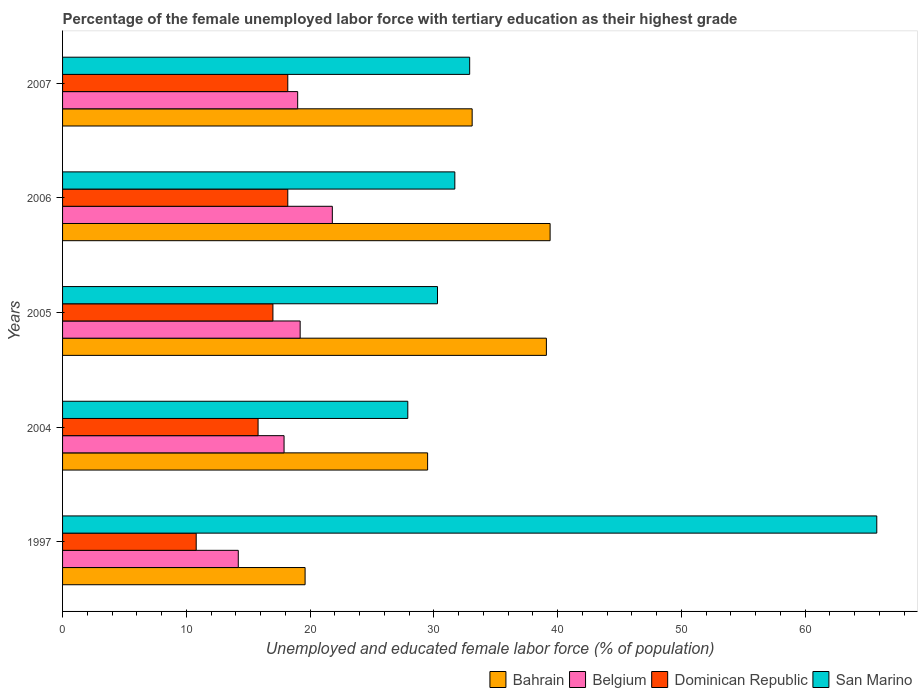How many bars are there on the 2nd tick from the top?
Your response must be concise. 4. What is the label of the 1st group of bars from the top?
Provide a succinct answer. 2007. What is the percentage of the unemployed female labor force with tertiary education in Bahrain in 1997?
Provide a succinct answer. 19.6. Across all years, what is the maximum percentage of the unemployed female labor force with tertiary education in San Marino?
Your answer should be compact. 65.8. Across all years, what is the minimum percentage of the unemployed female labor force with tertiary education in Dominican Republic?
Provide a succinct answer. 10.8. In which year was the percentage of the unemployed female labor force with tertiary education in Dominican Republic minimum?
Make the answer very short. 1997. What is the total percentage of the unemployed female labor force with tertiary education in Dominican Republic in the graph?
Your response must be concise. 80. What is the difference between the percentage of the unemployed female labor force with tertiary education in San Marino in 2006 and that in 2007?
Keep it short and to the point. -1.2. What is the difference between the percentage of the unemployed female labor force with tertiary education in Belgium in 2006 and the percentage of the unemployed female labor force with tertiary education in Dominican Republic in 1997?
Keep it short and to the point. 11. What is the average percentage of the unemployed female labor force with tertiary education in Belgium per year?
Offer a very short reply. 18.42. In the year 2005, what is the difference between the percentage of the unemployed female labor force with tertiary education in Belgium and percentage of the unemployed female labor force with tertiary education in Dominican Republic?
Make the answer very short. 2.2. What is the ratio of the percentage of the unemployed female labor force with tertiary education in San Marino in 1997 to that in 2005?
Provide a short and direct response. 2.17. Is the difference between the percentage of the unemployed female labor force with tertiary education in Belgium in 1997 and 2005 greater than the difference between the percentage of the unemployed female labor force with tertiary education in Dominican Republic in 1997 and 2005?
Offer a terse response. Yes. What is the difference between the highest and the second highest percentage of the unemployed female labor force with tertiary education in Belgium?
Provide a succinct answer. 2.6. What is the difference between the highest and the lowest percentage of the unemployed female labor force with tertiary education in Dominican Republic?
Offer a very short reply. 7.4. What does the 4th bar from the top in 2007 represents?
Offer a terse response. Bahrain. What does the 3rd bar from the bottom in 2006 represents?
Your answer should be very brief. Dominican Republic. Is it the case that in every year, the sum of the percentage of the unemployed female labor force with tertiary education in Dominican Republic and percentage of the unemployed female labor force with tertiary education in Bahrain is greater than the percentage of the unemployed female labor force with tertiary education in Belgium?
Your response must be concise. Yes. How many bars are there?
Ensure brevity in your answer.  20. Does the graph contain any zero values?
Your answer should be compact. No. Where does the legend appear in the graph?
Provide a short and direct response. Bottom right. How are the legend labels stacked?
Keep it short and to the point. Horizontal. What is the title of the graph?
Give a very brief answer. Percentage of the female unemployed labor force with tertiary education as their highest grade. Does "North America" appear as one of the legend labels in the graph?
Your answer should be very brief. No. What is the label or title of the X-axis?
Offer a terse response. Unemployed and educated female labor force (% of population). What is the Unemployed and educated female labor force (% of population) in Bahrain in 1997?
Your answer should be very brief. 19.6. What is the Unemployed and educated female labor force (% of population) in Belgium in 1997?
Your answer should be very brief. 14.2. What is the Unemployed and educated female labor force (% of population) of Dominican Republic in 1997?
Provide a succinct answer. 10.8. What is the Unemployed and educated female labor force (% of population) of San Marino in 1997?
Your answer should be very brief. 65.8. What is the Unemployed and educated female labor force (% of population) of Bahrain in 2004?
Offer a terse response. 29.5. What is the Unemployed and educated female labor force (% of population) of Belgium in 2004?
Give a very brief answer. 17.9. What is the Unemployed and educated female labor force (% of population) of Dominican Republic in 2004?
Offer a terse response. 15.8. What is the Unemployed and educated female labor force (% of population) of San Marino in 2004?
Your answer should be compact. 27.9. What is the Unemployed and educated female labor force (% of population) in Bahrain in 2005?
Ensure brevity in your answer.  39.1. What is the Unemployed and educated female labor force (% of population) in Belgium in 2005?
Make the answer very short. 19.2. What is the Unemployed and educated female labor force (% of population) in Dominican Republic in 2005?
Offer a very short reply. 17. What is the Unemployed and educated female labor force (% of population) in San Marino in 2005?
Provide a succinct answer. 30.3. What is the Unemployed and educated female labor force (% of population) in Bahrain in 2006?
Make the answer very short. 39.4. What is the Unemployed and educated female labor force (% of population) in Belgium in 2006?
Provide a short and direct response. 21.8. What is the Unemployed and educated female labor force (% of population) of Dominican Republic in 2006?
Provide a short and direct response. 18.2. What is the Unemployed and educated female labor force (% of population) in San Marino in 2006?
Your response must be concise. 31.7. What is the Unemployed and educated female labor force (% of population) of Bahrain in 2007?
Your answer should be compact. 33.1. What is the Unemployed and educated female labor force (% of population) of Dominican Republic in 2007?
Offer a very short reply. 18.2. What is the Unemployed and educated female labor force (% of population) in San Marino in 2007?
Ensure brevity in your answer.  32.9. Across all years, what is the maximum Unemployed and educated female labor force (% of population) in Bahrain?
Make the answer very short. 39.4. Across all years, what is the maximum Unemployed and educated female labor force (% of population) in Belgium?
Offer a terse response. 21.8. Across all years, what is the maximum Unemployed and educated female labor force (% of population) in Dominican Republic?
Your answer should be compact. 18.2. Across all years, what is the maximum Unemployed and educated female labor force (% of population) of San Marino?
Make the answer very short. 65.8. Across all years, what is the minimum Unemployed and educated female labor force (% of population) in Bahrain?
Keep it short and to the point. 19.6. Across all years, what is the minimum Unemployed and educated female labor force (% of population) in Belgium?
Provide a succinct answer. 14.2. Across all years, what is the minimum Unemployed and educated female labor force (% of population) in Dominican Republic?
Offer a very short reply. 10.8. Across all years, what is the minimum Unemployed and educated female labor force (% of population) of San Marino?
Make the answer very short. 27.9. What is the total Unemployed and educated female labor force (% of population) in Bahrain in the graph?
Ensure brevity in your answer.  160.7. What is the total Unemployed and educated female labor force (% of population) in Belgium in the graph?
Offer a terse response. 92.1. What is the total Unemployed and educated female labor force (% of population) of Dominican Republic in the graph?
Offer a terse response. 80. What is the total Unemployed and educated female labor force (% of population) in San Marino in the graph?
Your answer should be very brief. 188.6. What is the difference between the Unemployed and educated female labor force (% of population) of Dominican Republic in 1997 and that in 2004?
Offer a very short reply. -5. What is the difference between the Unemployed and educated female labor force (% of population) of San Marino in 1997 and that in 2004?
Your answer should be very brief. 37.9. What is the difference between the Unemployed and educated female labor force (% of population) of Bahrain in 1997 and that in 2005?
Make the answer very short. -19.5. What is the difference between the Unemployed and educated female labor force (% of population) of Dominican Republic in 1997 and that in 2005?
Keep it short and to the point. -6.2. What is the difference between the Unemployed and educated female labor force (% of population) of San Marino in 1997 and that in 2005?
Ensure brevity in your answer.  35.5. What is the difference between the Unemployed and educated female labor force (% of population) of Bahrain in 1997 and that in 2006?
Provide a short and direct response. -19.8. What is the difference between the Unemployed and educated female labor force (% of population) in Belgium in 1997 and that in 2006?
Keep it short and to the point. -7.6. What is the difference between the Unemployed and educated female labor force (% of population) of San Marino in 1997 and that in 2006?
Give a very brief answer. 34.1. What is the difference between the Unemployed and educated female labor force (% of population) in Bahrain in 1997 and that in 2007?
Your answer should be very brief. -13.5. What is the difference between the Unemployed and educated female labor force (% of population) of Dominican Republic in 1997 and that in 2007?
Ensure brevity in your answer.  -7.4. What is the difference between the Unemployed and educated female labor force (% of population) of San Marino in 1997 and that in 2007?
Your response must be concise. 32.9. What is the difference between the Unemployed and educated female labor force (% of population) in Bahrain in 2004 and that in 2005?
Give a very brief answer. -9.6. What is the difference between the Unemployed and educated female labor force (% of population) of San Marino in 2004 and that in 2005?
Ensure brevity in your answer.  -2.4. What is the difference between the Unemployed and educated female labor force (% of population) in Bahrain in 2004 and that in 2006?
Keep it short and to the point. -9.9. What is the difference between the Unemployed and educated female labor force (% of population) of Belgium in 2004 and that in 2006?
Provide a short and direct response. -3.9. What is the difference between the Unemployed and educated female labor force (% of population) of Dominican Republic in 2004 and that in 2006?
Keep it short and to the point. -2.4. What is the difference between the Unemployed and educated female labor force (% of population) in San Marino in 2004 and that in 2006?
Your response must be concise. -3.8. What is the difference between the Unemployed and educated female labor force (% of population) of San Marino in 2004 and that in 2007?
Provide a succinct answer. -5. What is the difference between the Unemployed and educated female labor force (% of population) in Dominican Republic in 2005 and that in 2006?
Provide a short and direct response. -1.2. What is the difference between the Unemployed and educated female labor force (% of population) in Belgium in 2005 and that in 2007?
Keep it short and to the point. 0.2. What is the difference between the Unemployed and educated female labor force (% of population) in San Marino in 2005 and that in 2007?
Provide a succinct answer. -2.6. What is the difference between the Unemployed and educated female labor force (% of population) in San Marino in 2006 and that in 2007?
Keep it short and to the point. -1.2. What is the difference between the Unemployed and educated female labor force (% of population) in Bahrain in 1997 and the Unemployed and educated female labor force (% of population) in Belgium in 2004?
Offer a very short reply. 1.7. What is the difference between the Unemployed and educated female labor force (% of population) in Belgium in 1997 and the Unemployed and educated female labor force (% of population) in Dominican Republic in 2004?
Provide a short and direct response. -1.6. What is the difference between the Unemployed and educated female labor force (% of population) in Belgium in 1997 and the Unemployed and educated female labor force (% of population) in San Marino in 2004?
Keep it short and to the point. -13.7. What is the difference between the Unemployed and educated female labor force (% of population) of Dominican Republic in 1997 and the Unemployed and educated female labor force (% of population) of San Marino in 2004?
Keep it short and to the point. -17.1. What is the difference between the Unemployed and educated female labor force (% of population) of Bahrain in 1997 and the Unemployed and educated female labor force (% of population) of Dominican Republic in 2005?
Provide a succinct answer. 2.6. What is the difference between the Unemployed and educated female labor force (% of population) of Bahrain in 1997 and the Unemployed and educated female labor force (% of population) of San Marino in 2005?
Ensure brevity in your answer.  -10.7. What is the difference between the Unemployed and educated female labor force (% of population) in Belgium in 1997 and the Unemployed and educated female labor force (% of population) in San Marino in 2005?
Offer a very short reply. -16.1. What is the difference between the Unemployed and educated female labor force (% of population) in Dominican Republic in 1997 and the Unemployed and educated female labor force (% of population) in San Marino in 2005?
Offer a terse response. -19.5. What is the difference between the Unemployed and educated female labor force (% of population) of Bahrain in 1997 and the Unemployed and educated female labor force (% of population) of Belgium in 2006?
Make the answer very short. -2.2. What is the difference between the Unemployed and educated female labor force (% of population) of Bahrain in 1997 and the Unemployed and educated female labor force (% of population) of Dominican Republic in 2006?
Offer a very short reply. 1.4. What is the difference between the Unemployed and educated female labor force (% of population) of Belgium in 1997 and the Unemployed and educated female labor force (% of population) of Dominican Republic in 2006?
Keep it short and to the point. -4. What is the difference between the Unemployed and educated female labor force (% of population) of Belgium in 1997 and the Unemployed and educated female labor force (% of population) of San Marino in 2006?
Provide a short and direct response. -17.5. What is the difference between the Unemployed and educated female labor force (% of population) of Dominican Republic in 1997 and the Unemployed and educated female labor force (% of population) of San Marino in 2006?
Your answer should be compact. -20.9. What is the difference between the Unemployed and educated female labor force (% of population) in Bahrain in 1997 and the Unemployed and educated female labor force (% of population) in Belgium in 2007?
Your answer should be very brief. 0.6. What is the difference between the Unemployed and educated female labor force (% of population) in Bahrain in 1997 and the Unemployed and educated female labor force (% of population) in San Marino in 2007?
Your response must be concise. -13.3. What is the difference between the Unemployed and educated female labor force (% of population) of Belgium in 1997 and the Unemployed and educated female labor force (% of population) of San Marino in 2007?
Your answer should be very brief. -18.7. What is the difference between the Unemployed and educated female labor force (% of population) of Dominican Republic in 1997 and the Unemployed and educated female labor force (% of population) of San Marino in 2007?
Your answer should be very brief. -22.1. What is the difference between the Unemployed and educated female labor force (% of population) in Bahrain in 2004 and the Unemployed and educated female labor force (% of population) in Dominican Republic in 2005?
Give a very brief answer. 12.5. What is the difference between the Unemployed and educated female labor force (% of population) of Belgium in 2004 and the Unemployed and educated female labor force (% of population) of Dominican Republic in 2005?
Your answer should be compact. 0.9. What is the difference between the Unemployed and educated female labor force (% of population) of Bahrain in 2004 and the Unemployed and educated female labor force (% of population) of Dominican Republic in 2006?
Your answer should be very brief. 11.3. What is the difference between the Unemployed and educated female labor force (% of population) in Dominican Republic in 2004 and the Unemployed and educated female labor force (% of population) in San Marino in 2006?
Provide a short and direct response. -15.9. What is the difference between the Unemployed and educated female labor force (% of population) in Bahrain in 2004 and the Unemployed and educated female labor force (% of population) in Belgium in 2007?
Give a very brief answer. 10.5. What is the difference between the Unemployed and educated female labor force (% of population) in Bahrain in 2004 and the Unemployed and educated female labor force (% of population) in San Marino in 2007?
Offer a very short reply. -3.4. What is the difference between the Unemployed and educated female labor force (% of population) in Belgium in 2004 and the Unemployed and educated female labor force (% of population) in San Marino in 2007?
Offer a terse response. -15. What is the difference between the Unemployed and educated female labor force (% of population) in Dominican Republic in 2004 and the Unemployed and educated female labor force (% of population) in San Marino in 2007?
Your answer should be compact. -17.1. What is the difference between the Unemployed and educated female labor force (% of population) in Bahrain in 2005 and the Unemployed and educated female labor force (% of population) in Dominican Republic in 2006?
Offer a terse response. 20.9. What is the difference between the Unemployed and educated female labor force (% of population) of Dominican Republic in 2005 and the Unemployed and educated female labor force (% of population) of San Marino in 2006?
Give a very brief answer. -14.7. What is the difference between the Unemployed and educated female labor force (% of population) of Bahrain in 2005 and the Unemployed and educated female labor force (% of population) of Belgium in 2007?
Offer a terse response. 20.1. What is the difference between the Unemployed and educated female labor force (% of population) of Bahrain in 2005 and the Unemployed and educated female labor force (% of population) of Dominican Republic in 2007?
Ensure brevity in your answer.  20.9. What is the difference between the Unemployed and educated female labor force (% of population) of Belgium in 2005 and the Unemployed and educated female labor force (% of population) of San Marino in 2007?
Make the answer very short. -13.7. What is the difference between the Unemployed and educated female labor force (% of population) of Dominican Republic in 2005 and the Unemployed and educated female labor force (% of population) of San Marino in 2007?
Offer a terse response. -15.9. What is the difference between the Unemployed and educated female labor force (% of population) of Bahrain in 2006 and the Unemployed and educated female labor force (% of population) of Belgium in 2007?
Ensure brevity in your answer.  20.4. What is the difference between the Unemployed and educated female labor force (% of population) of Bahrain in 2006 and the Unemployed and educated female labor force (% of population) of Dominican Republic in 2007?
Offer a terse response. 21.2. What is the difference between the Unemployed and educated female labor force (% of population) of Belgium in 2006 and the Unemployed and educated female labor force (% of population) of Dominican Republic in 2007?
Your response must be concise. 3.6. What is the difference between the Unemployed and educated female labor force (% of population) in Belgium in 2006 and the Unemployed and educated female labor force (% of population) in San Marino in 2007?
Provide a succinct answer. -11.1. What is the difference between the Unemployed and educated female labor force (% of population) of Dominican Republic in 2006 and the Unemployed and educated female labor force (% of population) of San Marino in 2007?
Provide a succinct answer. -14.7. What is the average Unemployed and educated female labor force (% of population) in Bahrain per year?
Offer a very short reply. 32.14. What is the average Unemployed and educated female labor force (% of population) of Belgium per year?
Your response must be concise. 18.42. What is the average Unemployed and educated female labor force (% of population) of Dominican Republic per year?
Your answer should be very brief. 16. What is the average Unemployed and educated female labor force (% of population) in San Marino per year?
Offer a terse response. 37.72. In the year 1997, what is the difference between the Unemployed and educated female labor force (% of population) in Bahrain and Unemployed and educated female labor force (% of population) in Dominican Republic?
Give a very brief answer. 8.8. In the year 1997, what is the difference between the Unemployed and educated female labor force (% of population) of Bahrain and Unemployed and educated female labor force (% of population) of San Marino?
Provide a short and direct response. -46.2. In the year 1997, what is the difference between the Unemployed and educated female labor force (% of population) of Belgium and Unemployed and educated female labor force (% of population) of Dominican Republic?
Ensure brevity in your answer.  3.4. In the year 1997, what is the difference between the Unemployed and educated female labor force (% of population) in Belgium and Unemployed and educated female labor force (% of population) in San Marino?
Make the answer very short. -51.6. In the year 1997, what is the difference between the Unemployed and educated female labor force (% of population) in Dominican Republic and Unemployed and educated female labor force (% of population) in San Marino?
Your answer should be very brief. -55. In the year 2004, what is the difference between the Unemployed and educated female labor force (% of population) in Bahrain and Unemployed and educated female labor force (% of population) in Belgium?
Offer a very short reply. 11.6. In the year 2004, what is the difference between the Unemployed and educated female labor force (% of population) in Belgium and Unemployed and educated female labor force (% of population) in Dominican Republic?
Your answer should be compact. 2.1. In the year 2004, what is the difference between the Unemployed and educated female labor force (% of population) of Belgium and Unemployed and educated female labor force (% of population) of San Marino?
Your response must be concise. -10. In the year 2005, what is the difference between the Unemployed and educated female labor force (% of population) of Bahrain and Unemployed and educated female labor force (% of population) of Belgium?
Make the answer very short. 19.9. In the year 2005, what is the difference between the Unemployed and educated female labor force (% of population) in Bahrain and Unemployed and educated female labor force (% of population) in Dominican Republic?
Make the answer very short. 22.1. In the year 2005, what is the difference between the Unemployed and educated female labor force (% of population) in Dominican Republic and Unemployed and educated female labor force (% of population) in San Marino?
Your response must be concise. -13.3. In the year 2006, what is the difference between the Unemployed and educated female labor force (% of population) of Bahrain and Unemployed and educated female labor force (% of population) of Belgium?
Offer a terse response. 17.6. In the year 2006, what is the difference between the Unemployed and educated female labor force (% of population) in Bahrain and Unemployed and educated female labor force (% of population) in Dominican Republic?
Your response must be concise. 21.2. In the year 2006, what is the difference between the Unemployed and educated female labor force (% of population) of Bahrain and Unemployed and educated female labor force (% of population) of San Marino?
Your answer should be very brief. 7.7. In the year 2006, what is the difference between the Unemployed and educated female labor force (% of population) in Belgium and Unemployed and educated female labor force (% of population) in San Marino?
Make the answer very short. -9.9. In the year 2007, what is the difference between the Unemployed and educated female labor force (% of population) of Bahrain and Unemployed and educated female labor force (% of population) of Belgium?
Keep it short and to the point. 14.1. In the year 2007, what is the difference between the Unemployed and educated female labor force (% of population) in Bahrain and Unemployed and educated female labor force (% of population) in Dominican Republic?
Provide a short and direct response. 14.9. In the year 2007, what is the difference between the Unemployed and educated female labor force (% of population) of Belgium and Unemployed and educated female labor force (% of population) of San Marino?
Give a very brief answer. -13.9. In the year 2007, what is the difference between the Unemployed and educated female labor force (% of population) in Dominican Republic and Unemployed and educated female labor force (% of population) in San Marino?
Keep it short and to the point. -14.7. What is the ratio of the Unemployed and educated female labor force (% of population) in Bahrain in 1997 to that in 2004?
Make the answer very short. 0.66. What is the ratio of the Unemployed and educated female labor force (% of population) in Belgium in 1997 to that in 2004?
Ensure brevity in your answer.  0.79. What is the ratio of the Unemployed and educated female labor force (% of population) in Dominican Republic in 1997 to that in 2004?
Provide a succinct answer. 0.68. What is the ratio of the Unemployed and educated female labor force (% of population) of San Marino in 1997 to that in 2004?
Make the answer very short. 2.36. What is the ratio of the Unemployed and educated female labor force (% of population) in Bahrain in 1997 to that in 2005?
Offer a terse response. 0.5. What is the ratio of the Unemployed and educated female labor force (% of population) of Belgium in 1997 to that in 2005?
Offer a very short reply. 0.74. What is the ratio of the Unemployed and educated female labor force (% of population) of Dominican Republic in 1997 to that in 2005?
Offer a very short reply. 0.64. What is the ratio of the Unemployed and educated female labor force (% of population) in San Marino in 1997 to that in 2005?
Ensure brevity in your answer.  2.17. What is the ratio of the Unemployed and educated female labor force (% of population) of Bahrain in 1997 to that in 2006?
Your answer should be compact. 0.5. What is the ratio of the Unemployed and educated female labor force (% of population) in Belgium in 1997 to that in 2006?
Provide a succinct answer. 0.65. What is the ratio of the Unemployed and educated female labor force (% of population) in Dominican Republic in 1997 to that in 2006?
Offer a very short reply. 0.59. What is the ratio of the Unemployed and educated female labor force (% of population) of San Marino in 1997 to that in 2006?
Provide a short and direct response. 2.08. What is the ratio of the Unemployed and educated female labor force (% of population) of Bahrain in 1997 to that in 2007?
Provide a short and direct response. 0.59. What is the ratio of the Unemployed and educated female labor force (% of population) of Belgium in 1997 to that in 2007?
Provide a succinct answer. 0.75. What is the ratio of the Unemployed and educated female labor force (% of population) of Dominican Republic in 1997 to that in 2007?
Keep it short and to the point. 0.59. What is the ratio of the Unemployed and educated female labor force (% of population) in Bahrain in 2004 to that in 2005?
Provide a succinct answer. 0.75. What is the ratio of the Unemployed and educated female labor force (% of population) in Belgium in 2004 to that in 2005?
Offer a very short reply. 0.93. What is the ratio of the Unemployed and educated female labor force (% of population) of Dominican Republic in 2004 to that in 2005?
Your response must be concise. 0.93. What is the ratio of the Unemployed and educated female labor force (% of population) in San Marino in 2004 to that in 2005?
Offer a very short reply. 0.92. What is the ratio of the Unemployed and educated female labor force (% of population) of Bahrain in 2004 to that in 2006?
Your answer should be very brief. 0.75. What is the ratio of the Unemployed and educated female labor force (% of population) in Belgium in 2004 to that in 2006?
Offer a terse response. 0.82. What is the ratio of the Unemployed and educated female labor force (% of population) of Dominican Republic in 2004 to that in 2006?
Keep it short and to the point. 0.87. What is the ratio of the Unemployed and educated female labor force (% of population) in San Marino in 2004 to that in 2006?
Provide a short and direct response. 0.88. What is the ratio of the Unemployed and educated female labor force (% of population) in Bahrain in 2004 to that in 2007?
Provide a succinct answer. 0.89. What is the ratio of the Unemployed and educated female labor force (% of population) of Belgium in 2004 to that in 2007?
Give a very brief answer. 0.94. What is the ratio of the Unemployed and educated female labor force (% of population) of Dominican Republic in 2004 to that in 2007?
Make the answer very short. 0.87. What is the ratio of the Unemployed and educated female labor force (% of population) of San Marino in 2004 to that in 2007?
Your response must be concise. 0.85. What is the ratio of the Unemployed and educated female labor force (% of population) of Belgium in 2005 to that in 2006?
Offer a terse response. 0.88. What is the ratio of the Unemployed and educated female labor force (% of population) of Dominican Republic in 2005 to that in 2006?
Your answer should be very brief. 0.93. What is the ratio of the Unemployed and educated female labor force (% of population) of San Marino in 2005 to that in 2006?
Give a very brief answer. 0.96. What is the ratio of the Unemployed and educated female labor force (% of population) in Bahrain in 2005 to that in 2007?
Your answer should be very brief. 1.18. What is the ratio of the Unemployed and educated female labor force (% of population) in Belgium in 2005 to that in 2007?
Your answer should be very brief. 1.01. What is the ratio of the Unemployed and educated female labor force (% of population) of Dominican Republic in 2005 to that in 2007?
Offer a very short reply. 0.93. What is the ratio of the Unemployed and educated female labor force (% of population) in San Marino in 2005 to that in 2007?
Provide a succinct answer. 0.92. What is the ratio of the Unemployed and educated female labor force (% of population) in Bahrain in 2006 to that in 2007?
Provide a short and direct response. 1.19. What is the ratio of the Unemployed and educated female labor force (% of population) of Belgium in 2006 to that in 2007?
Provide a succinct answer. 1.15. What is the ratio of the Unemployed and educated female labor force (% of population) in Dominican Republic in 2006 to that in 2007?
Your answer should be very brief. 1. What is the ratio of the Unemployed and educated female labor force (% of population) of San Marino in 2006 to that in 2007?
Keep it short and to the point. 0.96. What is the difference between the highest and the second highest Unemployed and educated female labor force (% of population) in Dominican Republic?
Make the answer very short. 0. What is the difference between the highest and the second highest Unemployed and educated female labor force (% of population) in San Marino?
Provide a succinct answer. 32.9. What is the difference between the highest and the lowest Unemployed and educated female labor force (% of population) in Bahrain?
Make the answer very short. 19.8. What is the difference between the highest and the lowest Unemployed and educated female labor force (% of population) of San Marino?
Your answer should be compact. 37.9. 